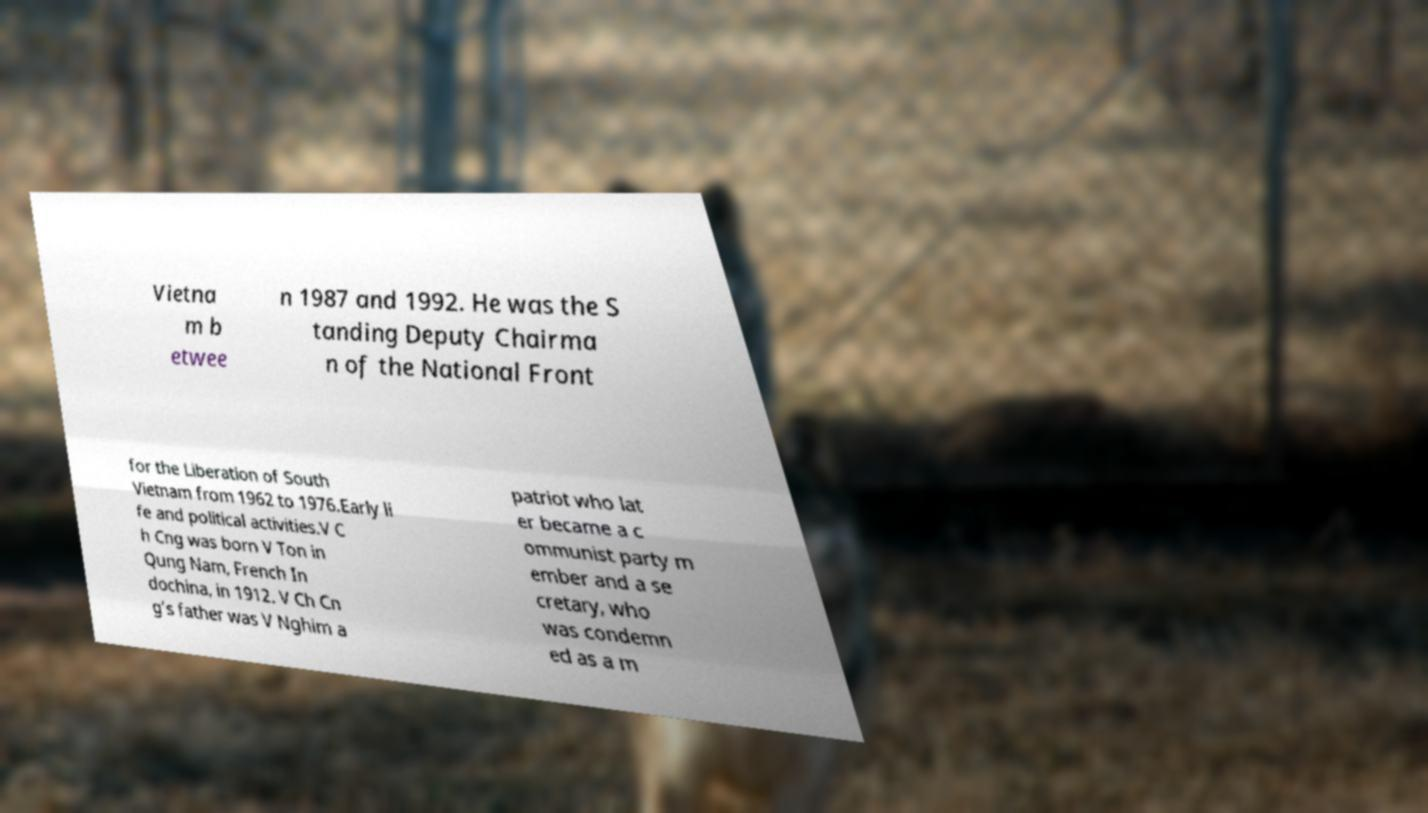Can you read and provide the text displayed in the image?This photo seems to have some interesting text. Can you extract and type it out for me? Vietna m b etwee n 1987 and 1992. He was the S tanding Deputy Chairma n of the National Front for the Liberation of South Vietnam from 1962 to 1976.Early li fe and political activities.V C h Cng was born V Ton in Qung Nam, French In dochina, in 1912. V Ch Cn g’s father was V Nghim a patriot who lat er became a c ommunist party m ember and a se cretary, who was condemn ed as a m 